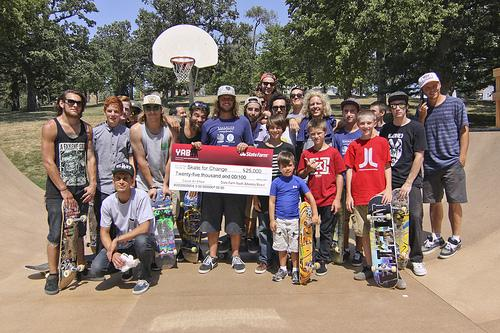In a few words, depict the scene involving two boys with red shirts. Two boys wearing red shirts are holding skateboards, standing near other people within a larger group. Briefly explain the possible reason behind the presence of a large red and white check in the image. The large red and white check might represent prize money to be awarded to a winner during a sports event or competition. What kind of sports equipment is present in the image? There are skateboards, a basketball goal, a basketball net, and a basketball ring. Determine whether the image quality is generally high or low, and provide a justification for the assessment. The image quality seems to be high, as multiple objects and people are clearly distinguishable, with detailed characteristics such as clothing, accessories, and features. Examine the interactions between objects or people in the image, and describe one noteworthy interaction. A man with shades on his head is placing his hand on another person's shoulder, possibly as a friendly gesture or to express congratulations. Assess the overall sentiment or emotion portrayed in this image. The image conveys a positive and cheerful atmosphere, as people are gathered together, possibly celebrating or enjoying a sports event. Provide a brief description of a person wearing a white hat in the image. A man wearing a white baseball cap, standing with his hand in his pocket, and possibly wearing sunglasses. Count the total number of people in the image. There are ten people in the image. Enumerate three features found in the image's background setting. Grass growing on the ground, trees growing in the distance, and a section of blue sky. Identify the main activity that is taking place within the image. A group of people standing together, some holding skateboards and a young man holding a large check. 